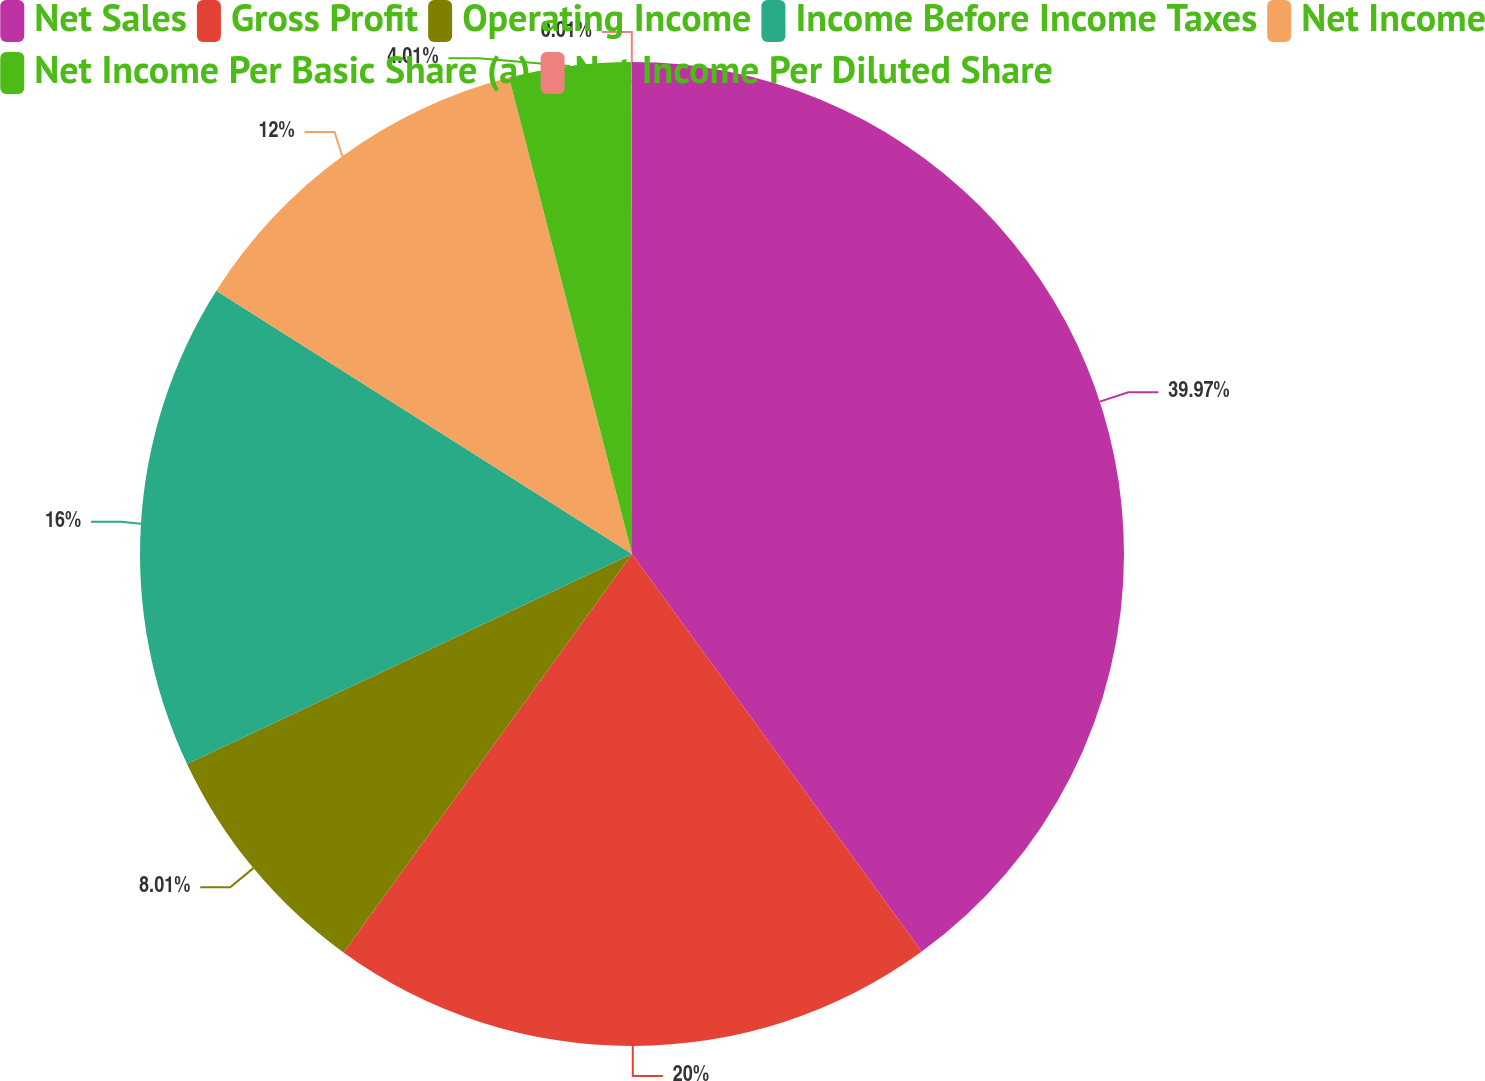Convert chart to OTSL. <chart><loc_0><loc_0><loc_500><loc_500><pie_chart><fcel>Net Sales<fcel>Gross Profit<fcel>Operating Income<fcel>Income Before Income Taxes<fcel>Net Income<fcel>Net Income Per Basic Share (a)<fcel>Net Income Per Diluted Share<nl><fcel>39.98%<fcel>20.0%<fcel>8.01%<fcel>16.0%<fcel>12.0%<fcel>4.01%<fcel>0.01%<nl></chart> 